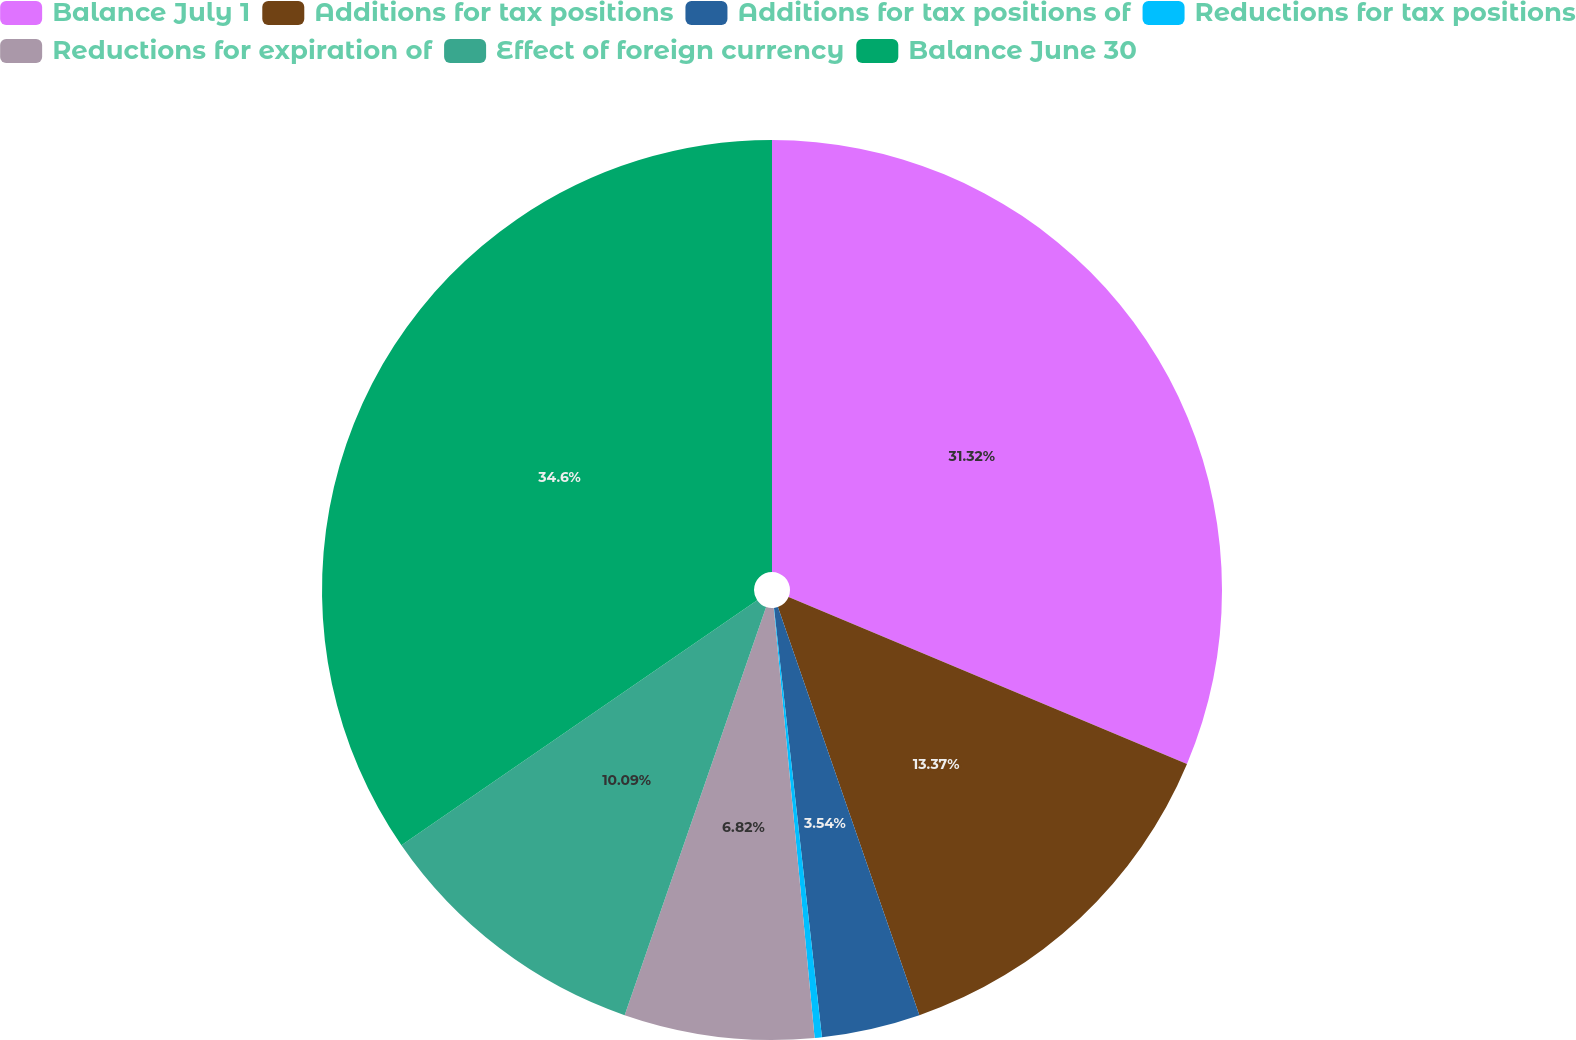Convert chart to OTSL. <chart><loc_0><loc_0><loc_500><loc_500><pie_chart><fcel>Balance July 1<fcel>Additions for tax positions<fcel>Additions for tax positions of<fcel>Reductions for tax positions<fcel>Reductions for expiration of<fcel>Effect of foreign currency<fcel>Balance June 30<nl><fcel>31.32%<fcel>13.37%<fcel>3.54%<fcel>0.26%<fcel>6.82%<fcel>10.09%<fcel>34.6%<nl></chart> 